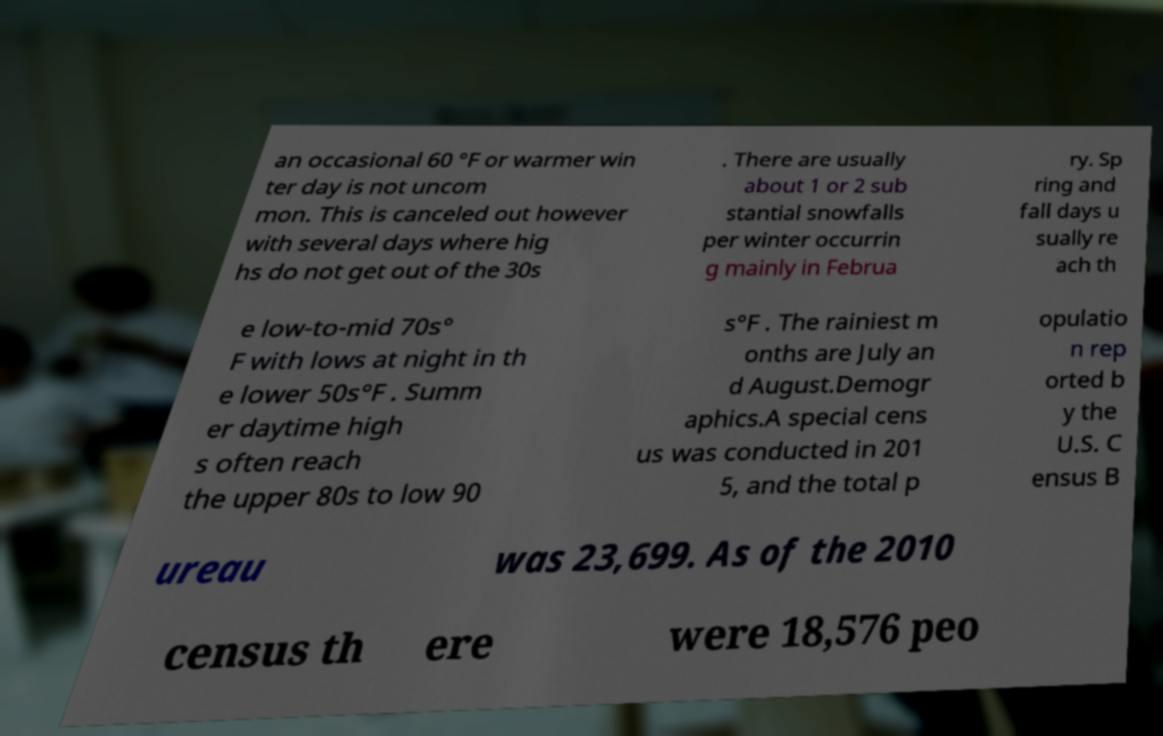Please identify and transcribe the text found in this image. an occasional 60 °F or warmer win ter day is not uncom mon. This is canceled out however with several days where hig hs do not get out of the 30s . There are usually about 1 or 2 sub stantial snowfalls per winter occurrin g mainly in Februa ry. Sp ring and fall days u sually re ach th e low-to-mid 70s° F with lows at night in th e lower 50s°F . Summ er daytime high s often reach the upper 80s to low 90 s°F . The rainiest m onths are July an d August.Demogr aphics.A special cens us was conducted in 201 5, and the total p opulatio n rep orted b y the U.S. C ensus B ureau was 23,699. As of the 2010 census th ere were 18,576 peo 